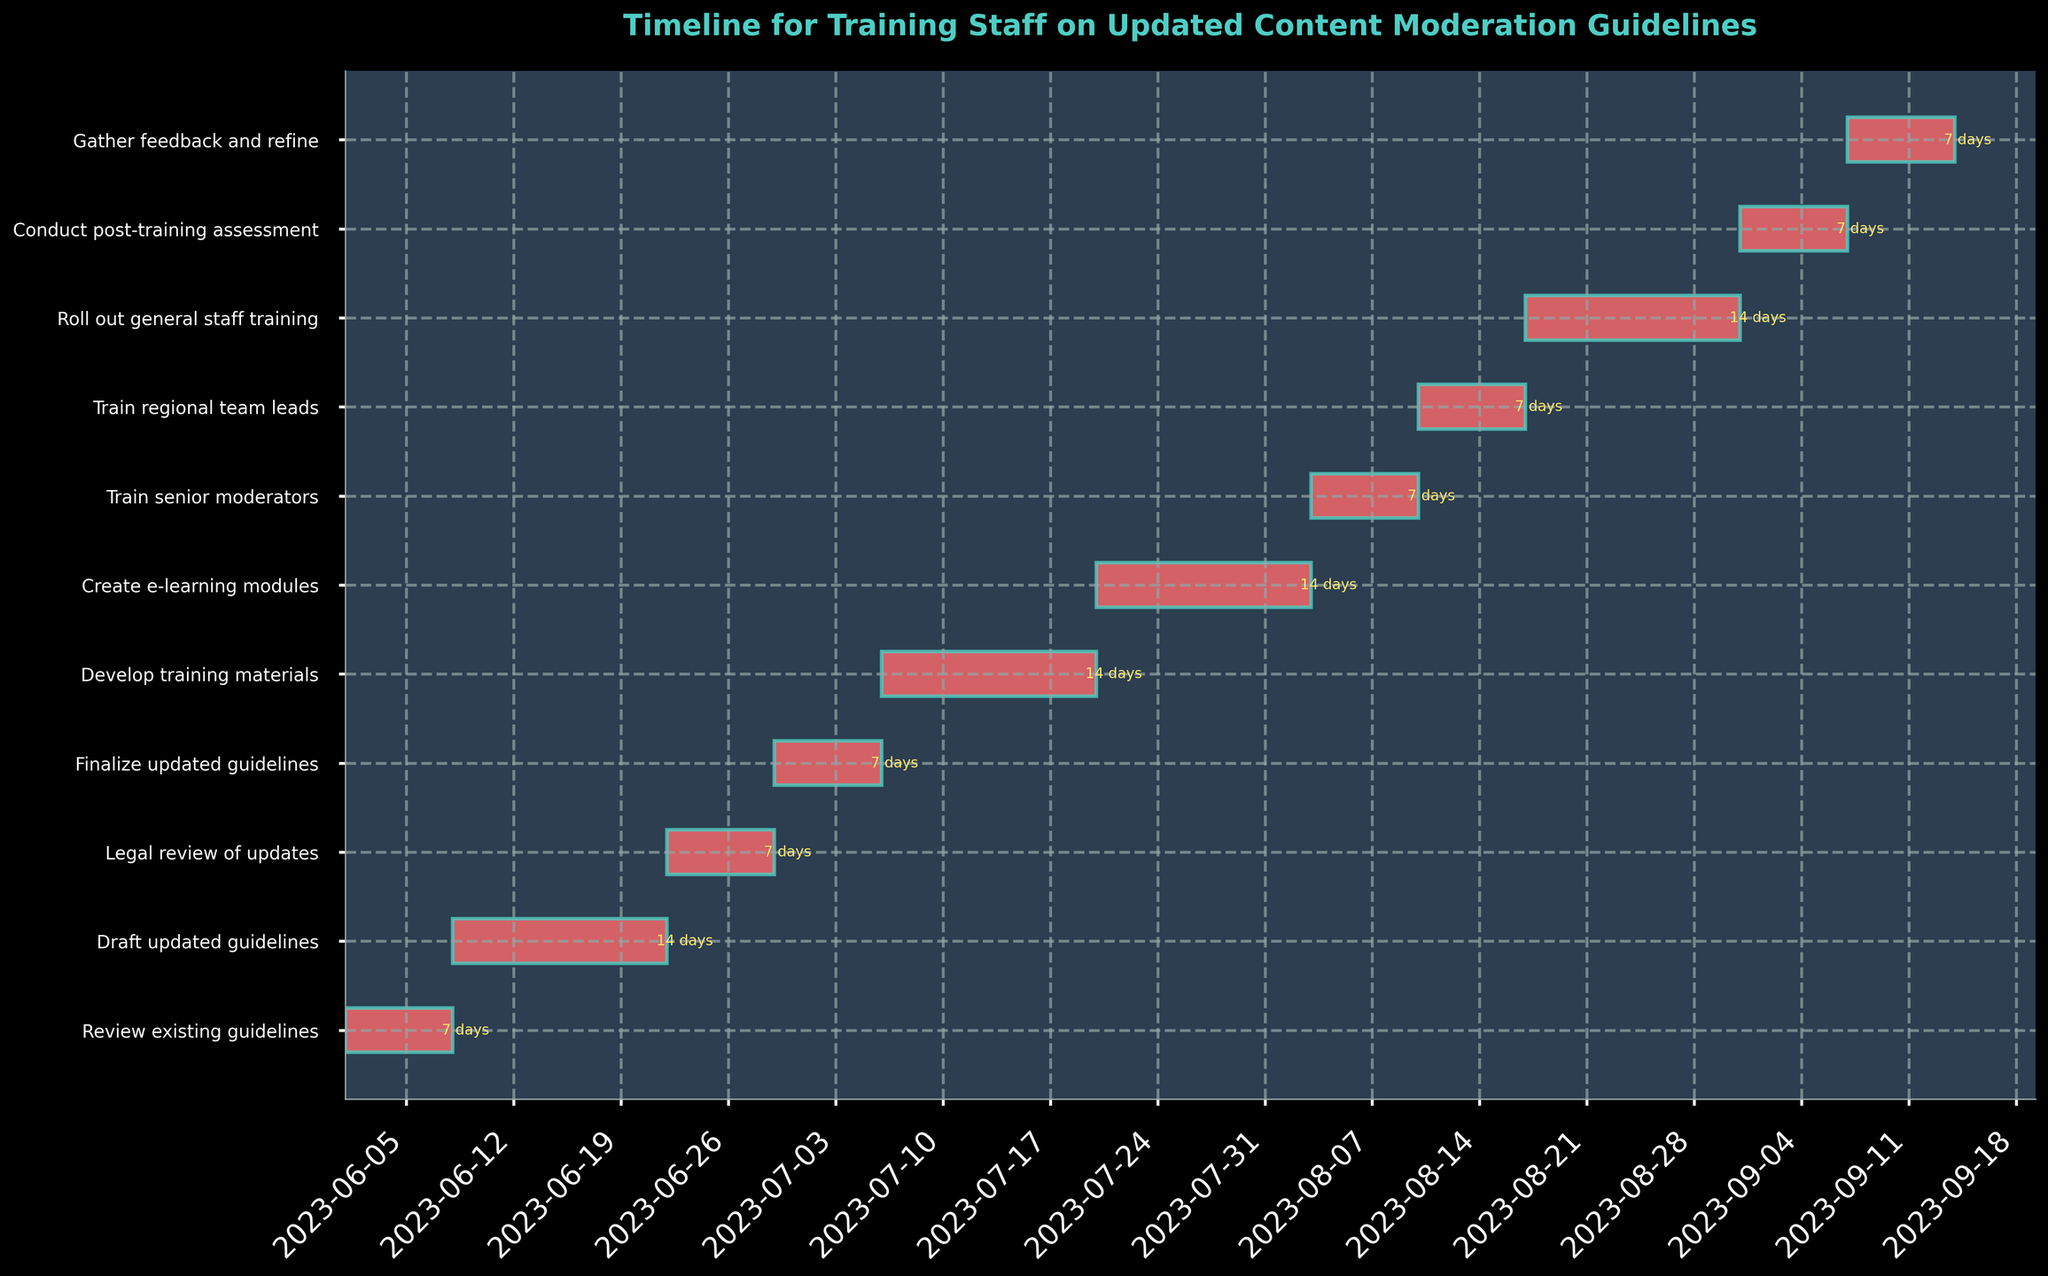What is the title of the Gantt chart? The title of the Gantt chart is usually placed prominently at the top of the figure. By reading the title, one can easily understand the overall focus of the chart.
Answer: Timeline for Training Staff on Updated Content Moderation Guidelines How many tasks are there in total? Each row in the Gantt chart typically represents a different task. By counting the number of rows, you can determine the total number of tasks represented.
Answer: 11 Which task has the longest duration? To identify the task with the longest duration, compare the lengths of the horizontal bars, considering the duration labels provided at the end of each bar.
Answer: Draft updated guidelines When does the 'Train senior moderators' task start and end? Locate the 'Train senior moderators' task on the y-axis, then read off the corresponding start and end dates from the x-axis or the duration bar.
Answer: Start: 2023-08-03, End: 2023-08-09 Which task ends the earliest? Find the task whose end date is the earliest by reading off the dates at the end of each horizontal bar and comparing them.
Answer: Review existing guidelines How many tasks have a duration of 7 days? Read the duration labels at the end of each task's bar to determine how many tasks have a duration of 7 days.
Answer: 6 What is the total duration of all tasks combined? Sum the durations of all tasks. The durations are provided at the end of each bar. This requires adding the durations: 7 + 14 + 7 + 7 + 14 + 14 + 7 + 7 + 14 + 7 + 7.
Answer: 105 days Which tasks are shorter than ‘Develop training materials’? Compare the duration of each task with the duration of ‘Develop training materials’, which is labeled as 14 days, to find the tasks that have a shorter duration.
Answer: Review existing guidelines, Legal review of updates, Finalize updated guidelines, Train senior moderators, Train regional team leads, Conduct post-training assessment, Gather feedback and refine Which tasks run in parallel with 'Create e-learning modules'? Identify the timeline for ‘Create e-learning modules’ (from 2023-07-20 to 2023-08-02) and check for any overlapping timelines with other tasks.
Answer: Develop training materials Between which two tasks does the 'Legal review of updates' task occur? Locate the 'Legal review of updates' task and identify the preceding and following tasks based on the timeline.
Answer: Draft updated guidelines and Finalize updated guidelines 